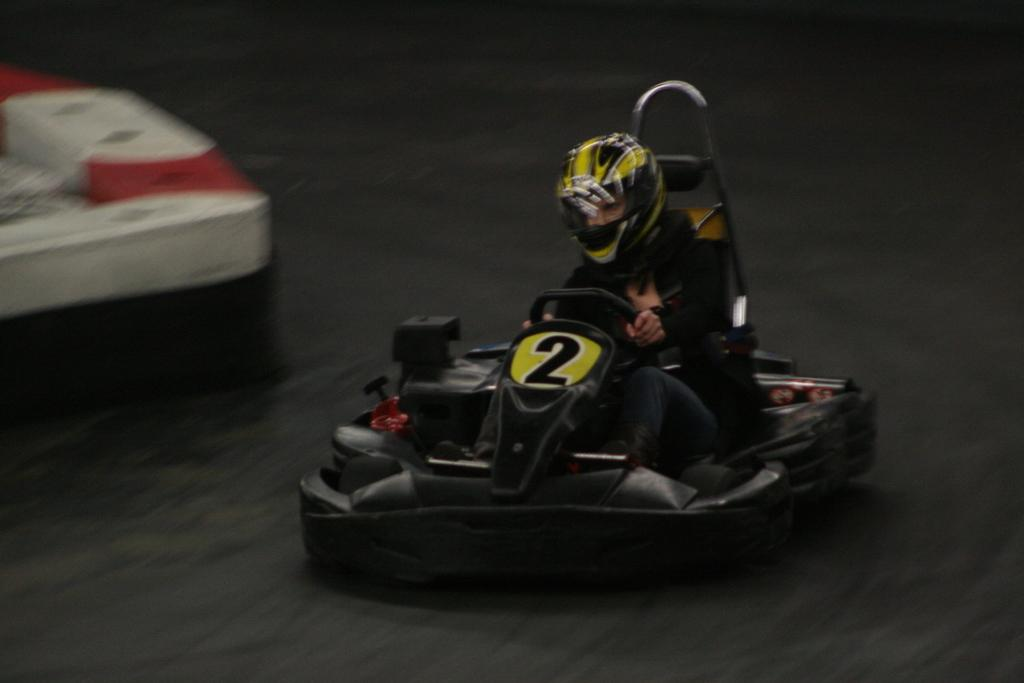What is the person in the image doing? The person is driving a go-kart in the image. What protective gear is the person wearing? The person is wearing a helmet in the image. Can you describe the object on the left side of the image? There is a white color object on the left side of the image. How does the pen help the person write while driving the go-kart? There is no pen present in the image, so it cannot help the person write while driving the go-kart. 